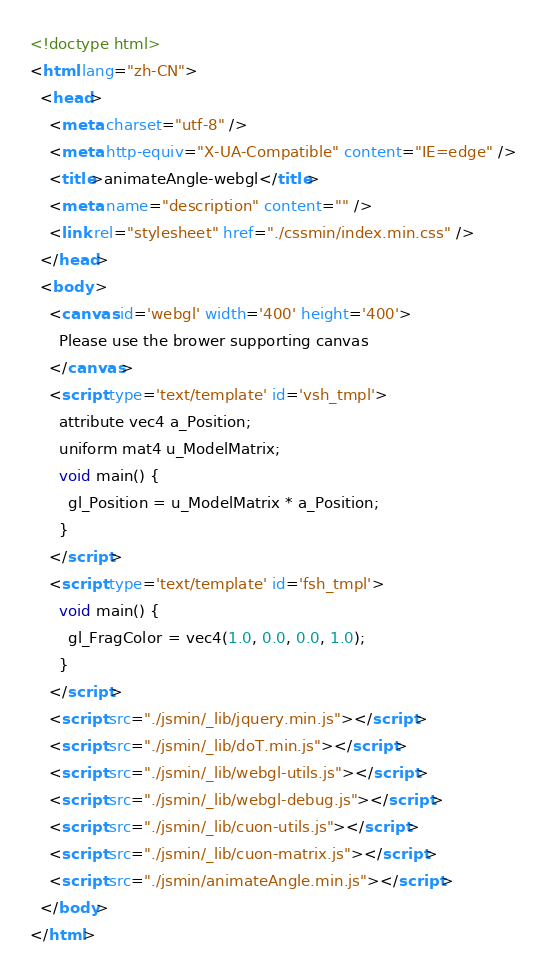<code> <loc_0><loc_0><loc_500><loc_500><_HTML_><!doctype html>
<html lang="zh-CN">
  <head>
    <meta charset="utf-8" />
    <meta http-equiv="X-UA-Compatible" content="IE=edge" />
    <title>animateAngle-webgl</title>
    <meta name="description" content="" />
    <link rel="stylesheet" href="./cssmin/index.min.css" />
  </head>
  <body >
    <canvas id='webgl' width='400' height='400'>
      Please use the brower supporting canvas
    </canvas>
    <script type='text/template' id='vsh_tmpl'>
      attribute vec4 a_Position;
      uniform mat4 u_ModelMatrix;
      void main() {
        gl_Position = u_ModelMatrix * a_Position;
      }
    </script>
    <script type='text/template' id='fsh_tmpl'>
      void main() {
        gl_FragColor = vec4(1.0, 0.0, 0.0, 1.0);
      }
    </script>
    <script src="./jsmin/_lib/jquery.min.js"></script>
    <script src="./jsmin/_lib/doT.min.js"></script>
    <script src="./jsmin/_lib/webgl-utils.js"></script>
    <script src="./jsmin/_lib/webgl-debug.js"></script>
    <script src="./jsmin/_lib/cuon-utils.js"></script>
    <script src="./jsmin/_lib/cuon-matrix.js"></script>
    <script src="./jsmin/animateAngle.min.js"></script>
  </body>
</html>
</code> 